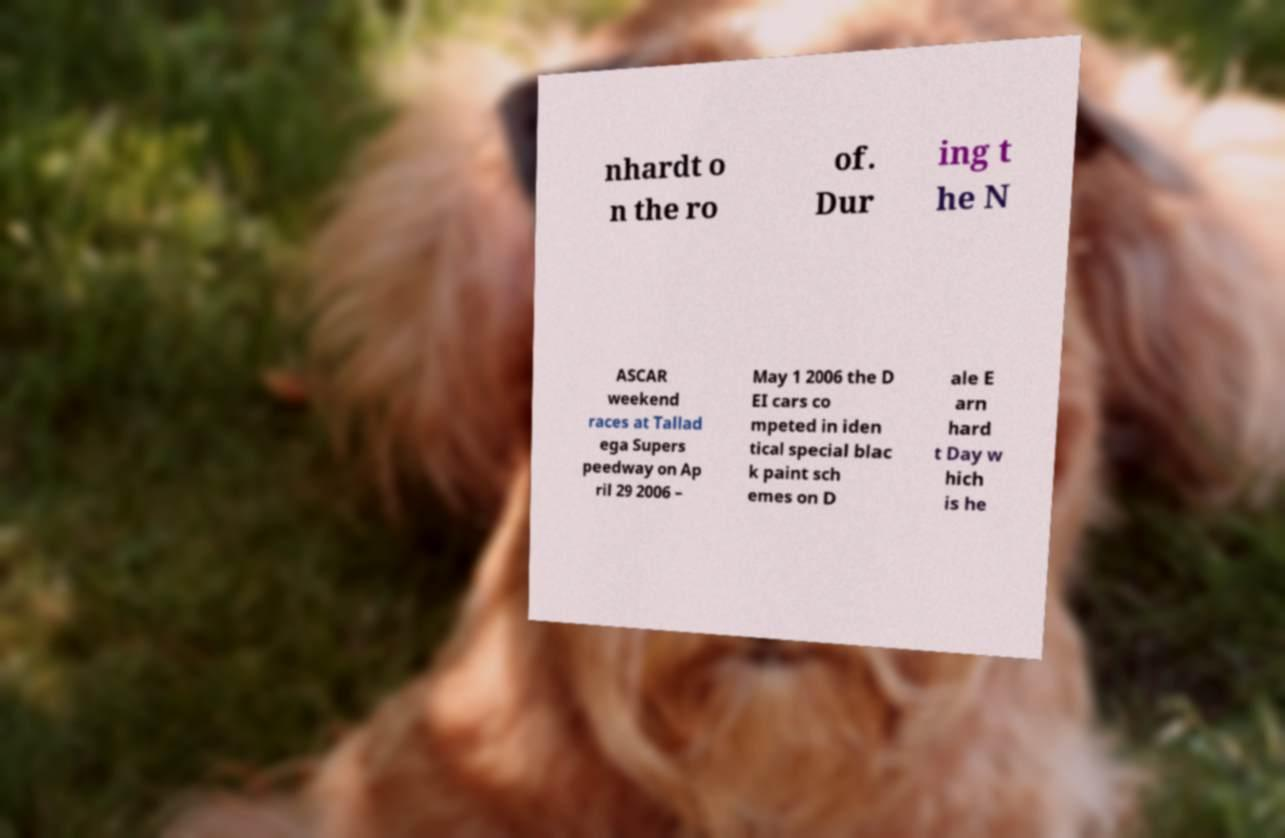What messages or text are displayed in this image? I need them in a readable, typed format. nhardt o n the ro of. Dur ing t he N ASCAR weekend races at Tallad ega Supers peedway on Ap ril 29 2006 – May 1 2006 the D EI cars co mpeted in iden tical special blac k paint sch emes on D ale E arn hard t Day w hich is he 